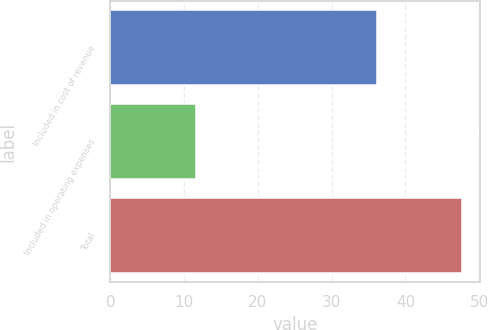Convert chart to OTSL. <chart><loc_0><loc_0><loc_500><loc_500><bar_chart><fcel>Included in cost of revenue<fcel>Included in operating expenses<fcel>Total<nl><fcel>36.1<fcel>11.6<fcel>47.7<nl></chart> 